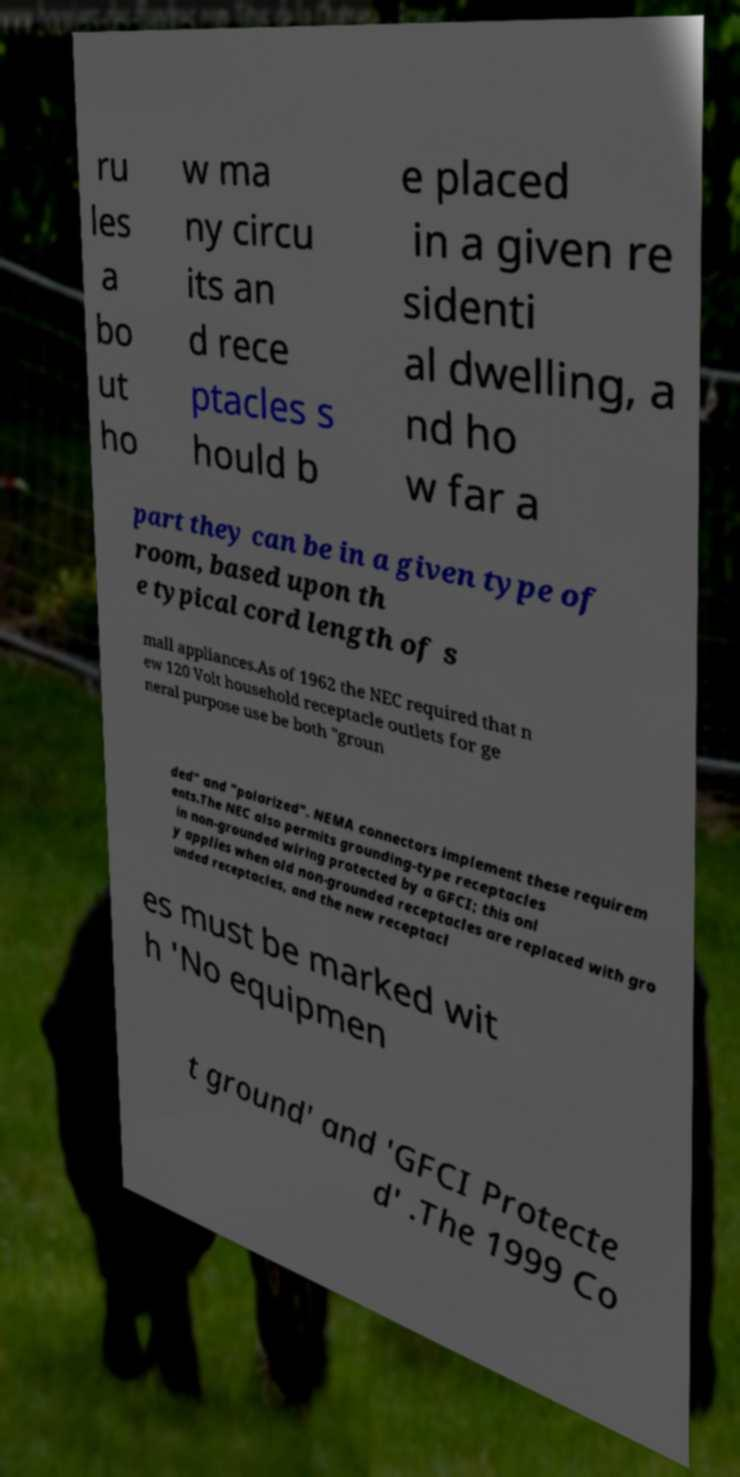Could you extract and type out the text from this image? ru les a bo ut ho w ma ny circu its an d rece ptacles s hould b e placed in a given re sidenti al dwelling, a nd ho w far a part they can be in a given type of room, based upon th e typical cord length of s mall appliances.As of 1962 the NEC required that n ew 120 Volt household receptacle outlets for ge neral purpose use be both "groun ded" and "polarized". NEMA connectors implement these requirem ents.The NEC also permits grounding-type receptacles in non-grounded wiring protected by a GFCI; this onl y applies when old non-grounded receptacles are replaced with gro unded receptacles, and the new receptacl es must be marked wit h 'No equipmen t ground' and 'GFCI Protecte d' .The 1999 Co 